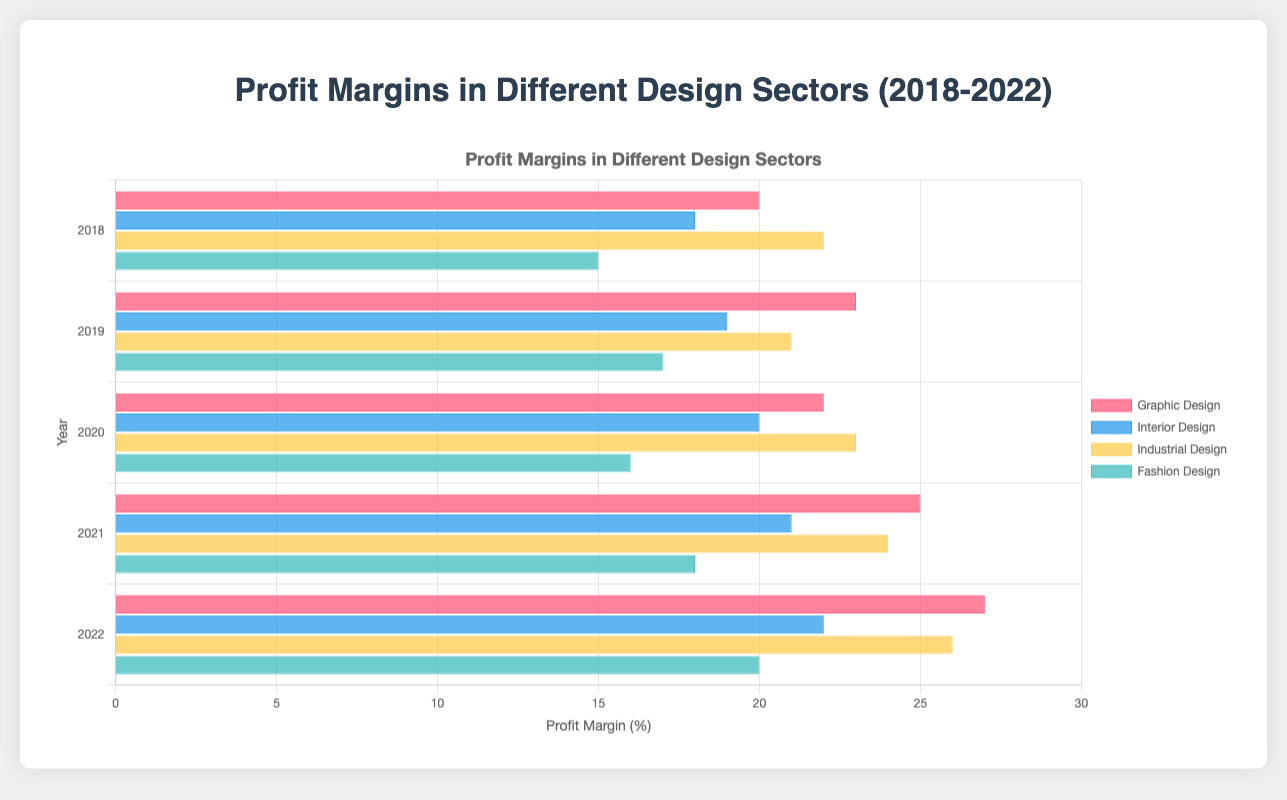What's the trend in profit margins for Interior Design from 2018 to 2022? Look at the blue bars representing Interior Design across the years. The profit margins increase from 18% in 2018 to 22% in 2022.
Answer: Increasing Which sector had the highest profit margin in 2022? Check the length of the bars in 2022. The yellow bar for Industrial Design is the longest, indicating the highest profit margin.
Answer: Industrial Design Compare the profit margins of Graphic Design versus Fashion Design in 2020. Which is higher? Compare the red bar for Graphic Design with the green bar for Fashion Design in 2020. The Graphic Design bar (22%) is higher than the Fashion Design bar (16%).
Answer: Graphic Design What is the average profit margin for Industrial Design across all years? Summarize the yellow bars for Industrial Design: (22 + 21 + 23 + 24 + 26) / 5.
Answer: 23.2 Which year's Graphic Design sector had the highest profit margin? Look at the red bars for Graphic Design. The highest bar, 27%, is in 2022.
Answer: 2022 By how much did the profit margin of Fashion Design increase from 2018 to 2019? Compare the green bars for Fashion Design in 2018 and 2019. The profit margin increased from 15% to 17%, so the increase is 2%.
Answer: 2% Which design sector showed the most consistent profit margins from 2018 to 2022? Evaluate the bars' heights for consistent heights. Fashion Design shows the smallest variability.
Answer: Fashion Design What is the difference in profit margin between Interior Design and Graphic Design in 2021? Compare the blue bar for Interior Design and the red bar for Graphic Design in 2021. The difference is 25% - 21% = 4%.
Answer: 4% How did Industrial Design's profit margin change from 2019 to 2020? Compare the yellow bars in 2019 and 2020. The margin increased from 21% to 23%, showing an increase of 2%.
Answer: Increased by 2% 